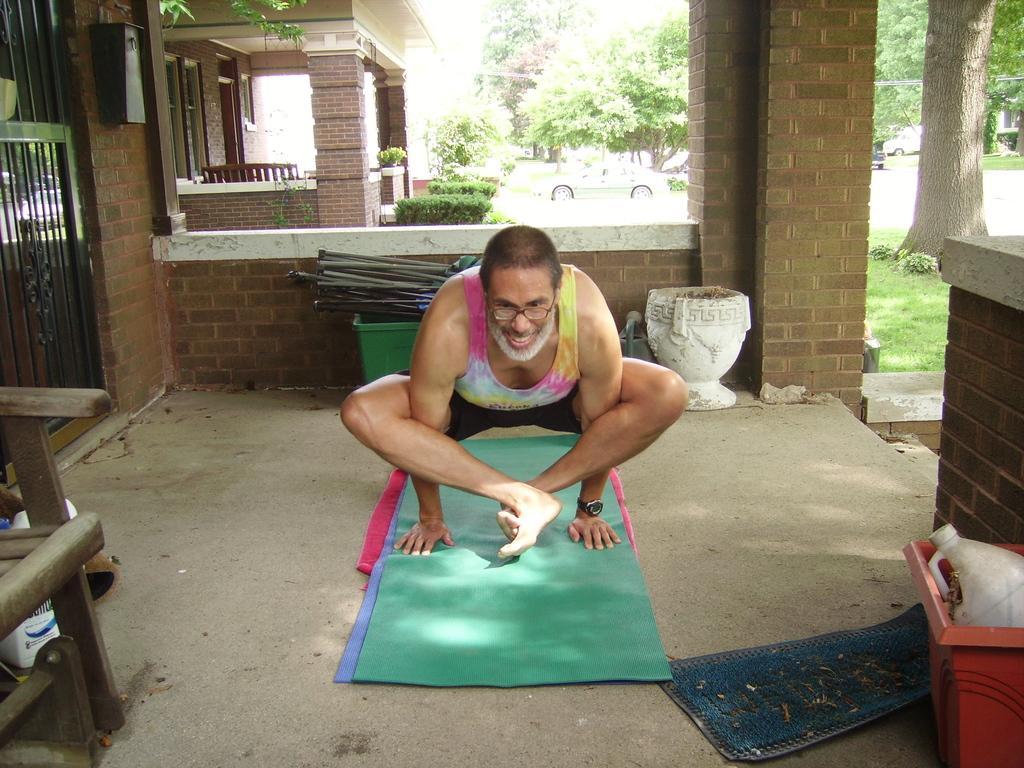How would you summarize this image in a sentence or two? In this image I can see the person and I can see few mats in green, purple and pink color. In front I can see the chair, background I can see the railing, few buildings, vehicles and few trees in green color. 